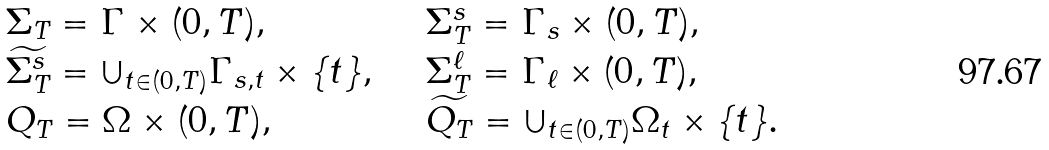Convert formula to latex. <formula><loc_0><loc_0><loc_500><loc_500>\begin{array} { l l } \Sigma _ { T } = \Gamma \times ( 0 , T ) , & \quad \Sigma ^ { s } _ { T } = \Gamma _ { s } \times ( 0 , T ) , \\ \widetilde { \Sigma ^ { s } _ { T } } = \cup _ { t \in ( 0 , T ) } \Gamma _ { s , t } \times \{ t \} , & \quad \Sigma ^ { \ell } _ { T } = \Gamma _ { \ell } \times ( 0 , T ) , \\ Q _ { T } = \Omega \times ( 0 , T ) , & \quad \widetilde { Q _ { T } } = \cup _ { t \in ( 0 , T ) } \Omega _ { t } \times \{ t \} . \end{array}</formula> 